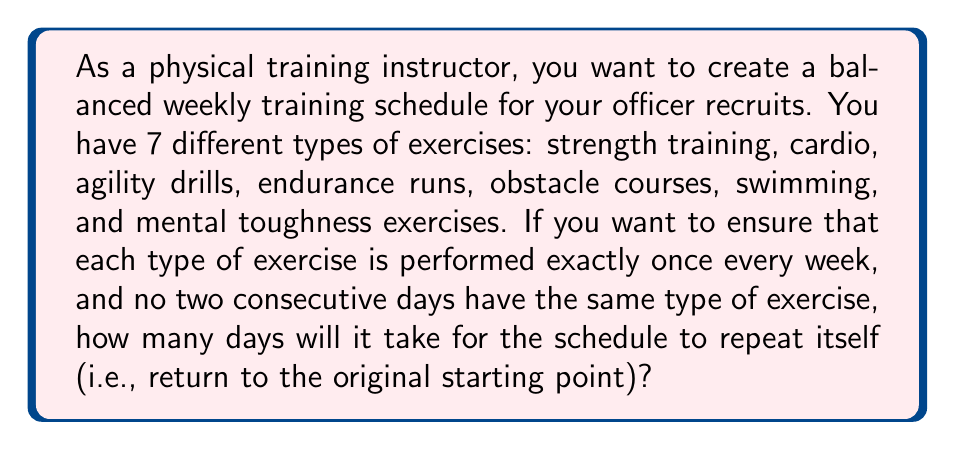What is the answer to this math problem? Let's approach this step-by-step using modular arithmetic:

1) We have 7 types of exercises, so we'll be working in modulo 7.

2) Each day, we need to choose a different exercise from the previous day. This means we're looking for a number $k$ such that:

   $$k \equiv 1 \pmod{7}$$
   $$2k \equiv 2 \pmod{7}$$
   $$3k \equiv 3 \pmod{7}$$
   $$4k \equiv 4 \pmod{7}$$
   $$5k \equiv 5 \pmod{7}$$
   $$6k \equiv 6 \pmod{7}$$
   $$7k \equiv 0 \pmod{7}$$

3) The smallest positive integer $k$ that satisfies all these conditions is 8.

4) Let's verify:
   $$8 \equiv 1 \pmod{7}$$
   $$16 \equiv 2 \pmod{7}$$
   $$24 \equiv 3 \pmod{7}$$
   $$32 \equiv 4 \pmod{7}$$
   $$40 \equiv 5 \pmod{7}$$
   $$48 \equiv 6 \pmod{7}$$
   $$56 \equiv 0 \pmod{7}$$

5) This means that after 7 days, the schedule will repeat.

6) We can also understand this result intuitively: since we have 7 types of exercises and each must be done once per week, it will take exactly 7 days for the schedule to complete one full cycle.

Therefore, the schedule will repeat itself after 7 days.
Answer: 7 days 